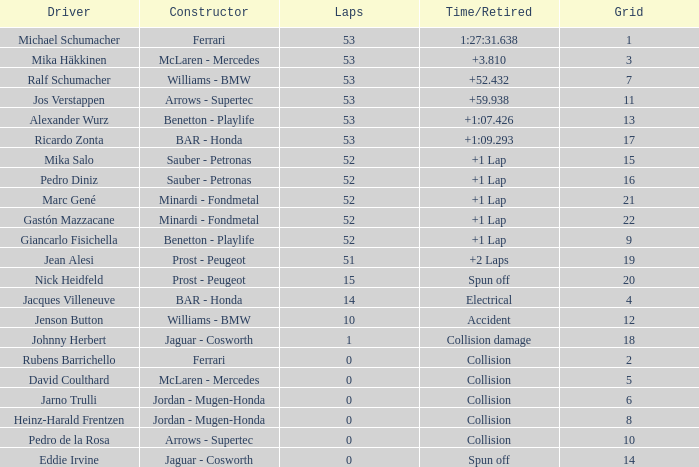How many circuits did ricardo zonta complete? 53.0. 